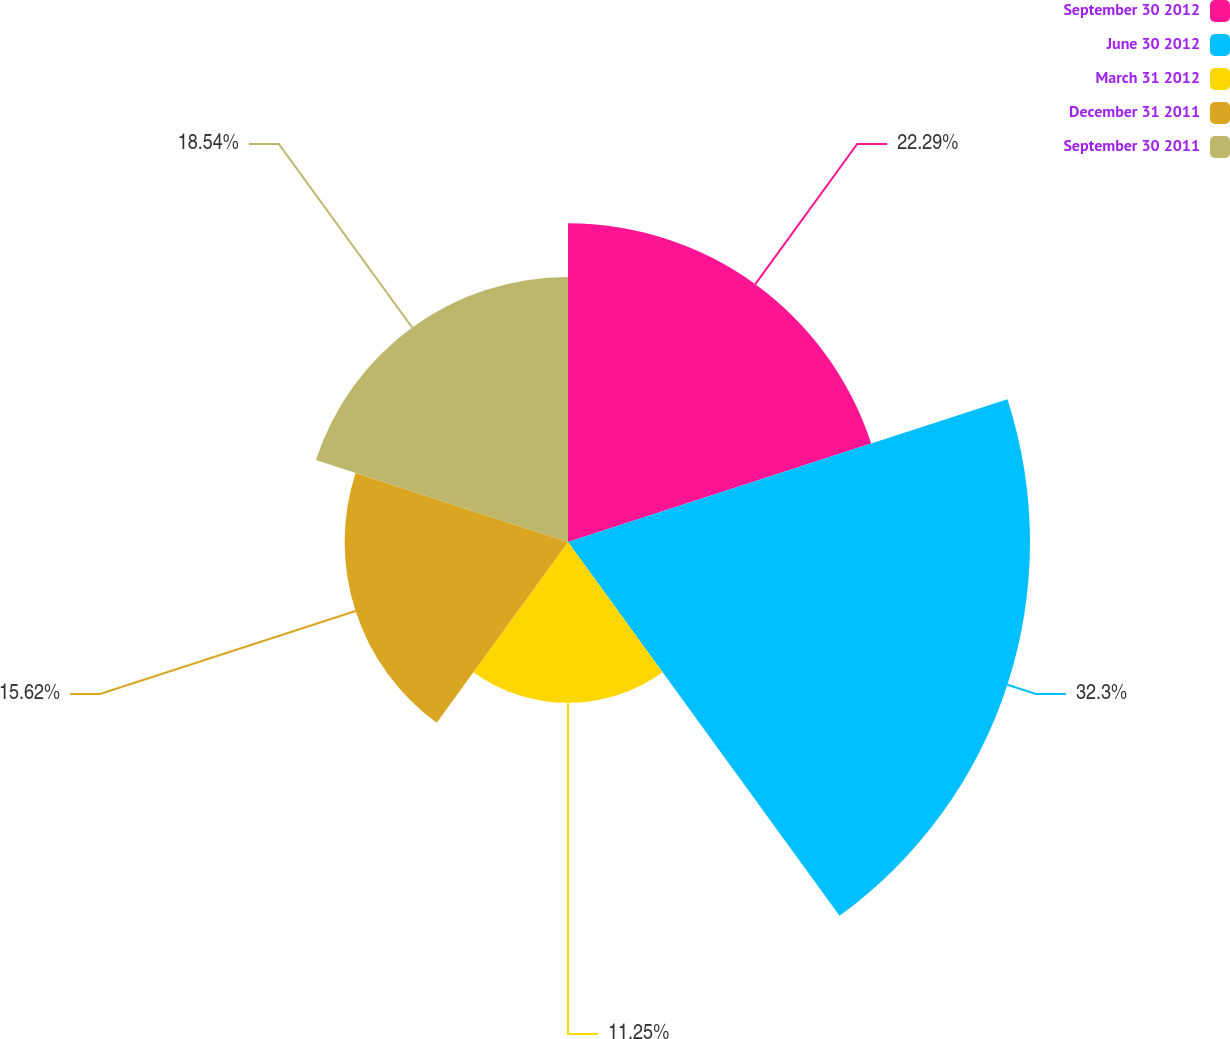Convert chart to OTSL. <chart><loc_0><loc_0><loc_500><loc_500><pie_chart><fcel>September 30 2012<fcel>June 30 2012<fcel>March 31 2012<fcel>December 31 2011<fcel>September 30 2011<nl><fcel>22.29%<fcel>32.31%<fcel>11.25%<fcel>15.62%<fcel>18.54%<nl></chart> 